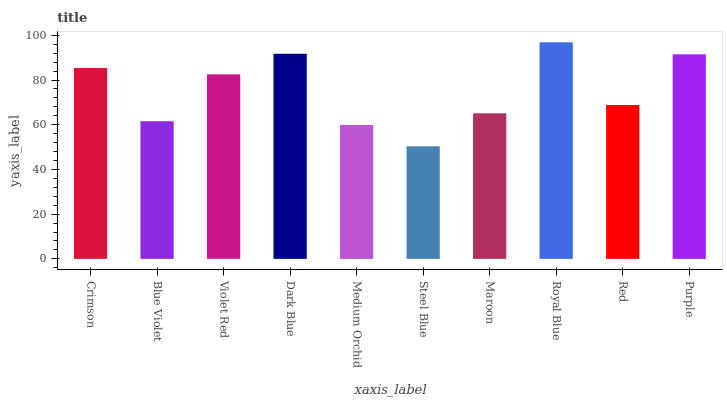Is Blue Violet the minimum?
Answer yes or no. No. Is Blue Violet the maximum?
Answer yes or no. No. Is Crimson greater than Blue Violet?
Answer yes or no. Yes. Is Blue Violet less than Crimson?
Answer yes or no. Yes. Is Blue Violet greater than Crimson?
Answer yes or no. No. Is Crimson less than Blue Violet?
Answer yes or no. No. Is Violet Red the high median?
Answer yes or no. Yes. Is Red the low median?
Answer yes or no. Yes. Is Dark Blue the high median?
Answer yes or no. No. Is Steel Blue the low median?
Answer yes or no. No. 